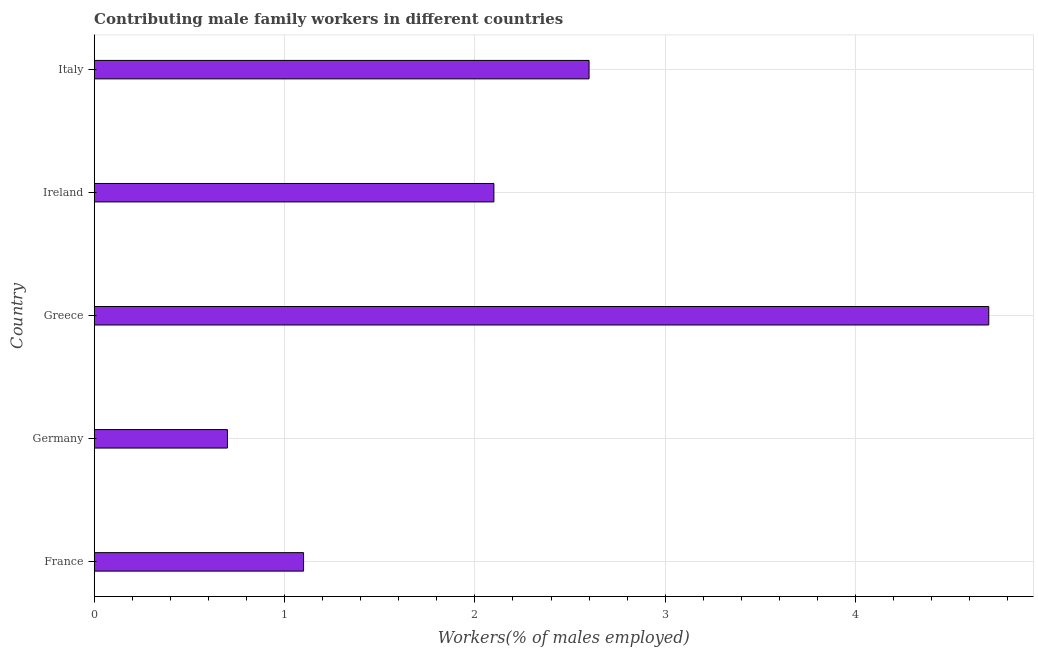Does the graph contain grids?
Ensure brevity in your answer.  Yes. What is the title of the graph?
Keep it short and to the point. Contributing male family workers in different countries. What is the label or title of the X-axis?
Provide a succinct answer. Workers(% of males employed). What is the contributing male family workers in Germany?
Provide a short and direct response. 0.7. Across all countries, what is the maximum contributing male family workers?
Ensure brevity in your answer.  4.7. Across all countries, what is the minimum contributing male family workers?
Ensure brevity in your answer.  0.7. In which country was the contributing male family workers maximum?
Provide a short and direct response. Greece. In which country was the contributing male family workers minimum?
Your answer should be compact. Germany. What is the sum of the contributing male family workers?
Offer a very short reply. 11.2. What is the difference between the contributing male family workers in France and Ireland?
Make the answer very short. -1. What is the average contributing male family workers per country?
Your response must be concise. 2.24. What is the median contributing male family workers?
Provide a short and direct response. 2.1. What is the ratio of the contributing male family workers in Germany to that in Italy?
Your response must be concise. 0.27. Is the contributing male family workers in France less than that in Italy?
Give a very brief answer. Yes. Is the difference between the contributing male family workers in Greece and Ireland greater than the difference between any two countries?
Keep it short and to the point. No. What is the difference between the highest and the second highest contributing male family workers?
Provide a short and direct response. 2.1. Is the sum of the contributing male family workers in Greece and Italy greater than the maximum contributing male family workers across all countries?
Give a very brief answer. Yes. What is the difference between the highest and the lowest contributing male family workers?
Keep it short and to the point. 4. How many bars are there?
Provide a succinct answer. 5. Are all the bars in the graph horizontal?
Offer a very short reply. Yes. What is the Workers(% of males employed) in France?
Your answer should be very brief. 1.1. What is the Workers(% of males employed) in Germany?
Offer a very short reply. 0.7. What is the Workers(% of males employed) in Greece?
Your answer should be very brief. 4.7. What is the Workers(% of males employed) in Ireland?
Your answer should be very brief. 2.1. What is the Workers(% of males employed) of Italy?
Your response must be concise. 2.6. What is the difference between the Workers(% of males employed) in France and Germany?
Your answer should be compact. 0.4. What is the difference between the Workers(% of males employed) in France and Greece?
Your response must be concise. -3.6. What is the difference between the Workers(% of males employed) in France and Ireland?
Make the answer very short. -1. What is the difference between the Workers(% of males employed) in France and Italy?
Offer a terse response. -1.5. What is the difference between the Workers(% of males employed) in Germany and Ireland?
Provide a succinct answer. -1.4. What is the difference between the Workers(% of males employed) in Greece and Ireland?
Offer a very short reply. 2.6. What is the difference between the Workers(% of males employed) in Ireland and Italy?
Provide a short and direct response. -0.5. What is the ratio of the Workers(% of males employed) in France to that in Germany?
Ensure brevity in your answer.  1.57. What is the ratio of the Workers(% of males employed) in France to that in Greece?
Your response must be concise. 0.23. What is the ratio of the Workers(% of males employed) in France to that in Ireland?
Give a very brief answer. 0.52. What is the ratio of the Workers(% of males employed) in France to that in Italy?
Ensure brevity in your answer.  0.42. What is the ratio of the Workers(% of males employed) in Germany to that in Greece?
Your response must be concise. 0.15. What is the ratio of the Workers(% of males employed) in Germany to that in Ireland?
Offer a very short reply. 0.33. What is the ratio of the Workers(% of males employed) in Germany to that in Italy?
Provide a succinct answer. 0.27. What is the ratio of the Workers(% of males employed) in Greece to that in Ireland?
Your answer should be compact. 2.24. What is the ratio of the Workers(% of males employed) in Greece to that in Italy?
Your answer should be compact. 1.81. What is the ratio of the Workers(% of males employed) in Ireland to that in Italy?
Offer a very short reply. 0.81. 